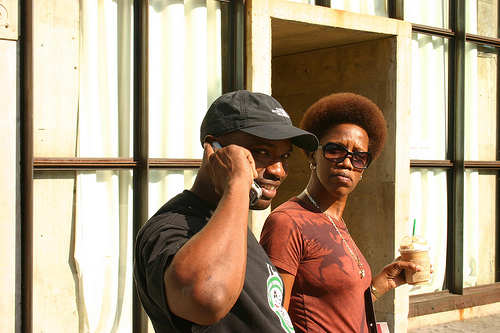How many people are there? 2 